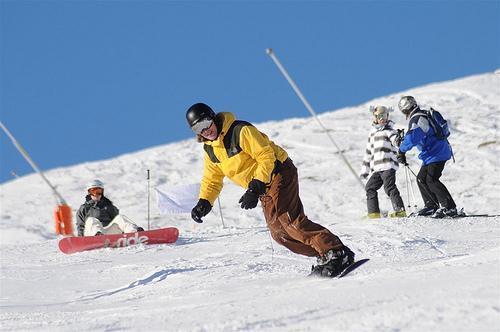How many people are in the picture?
Give a very brief answer. 3. How many bears are in the chair?
Give a very brief answer. 0. 